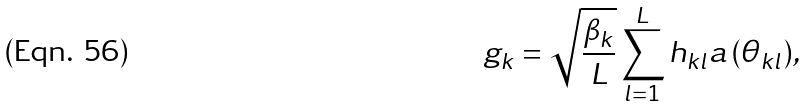Convert formula to latex. <formula><loc_0><loc_0><loc_500><loc_500>g _ { k } = \sqrt { \frac { \beta _ { k } } { L } } \sum _ { l = 1 } ^ { L } { h _ { k l } a \left ( \theta _ { k l } \right ) } ,</formula> 